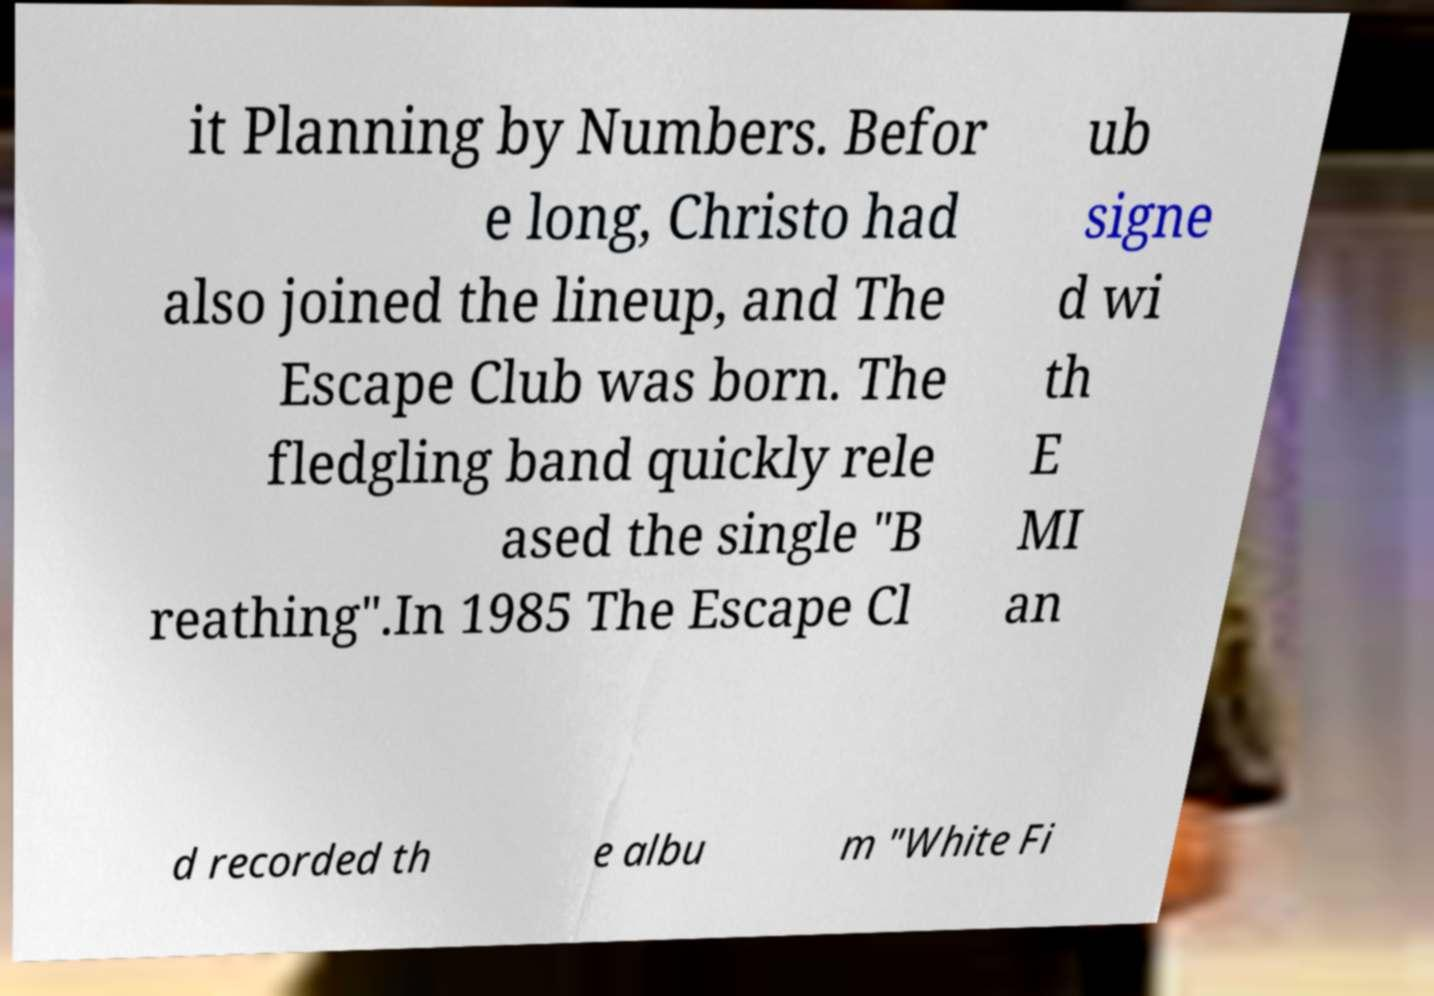Please read and relay the text visible in this image. What does it say? it Planning by Numbers. Befor e long, Christo had also joined the lineup, and The Escape Club was born. The fledgling band quickly rele ased the single "B reathing".In 1985 The Escape Cl ub signe d wi th E MI an d recorded th e albu m "White Fi 